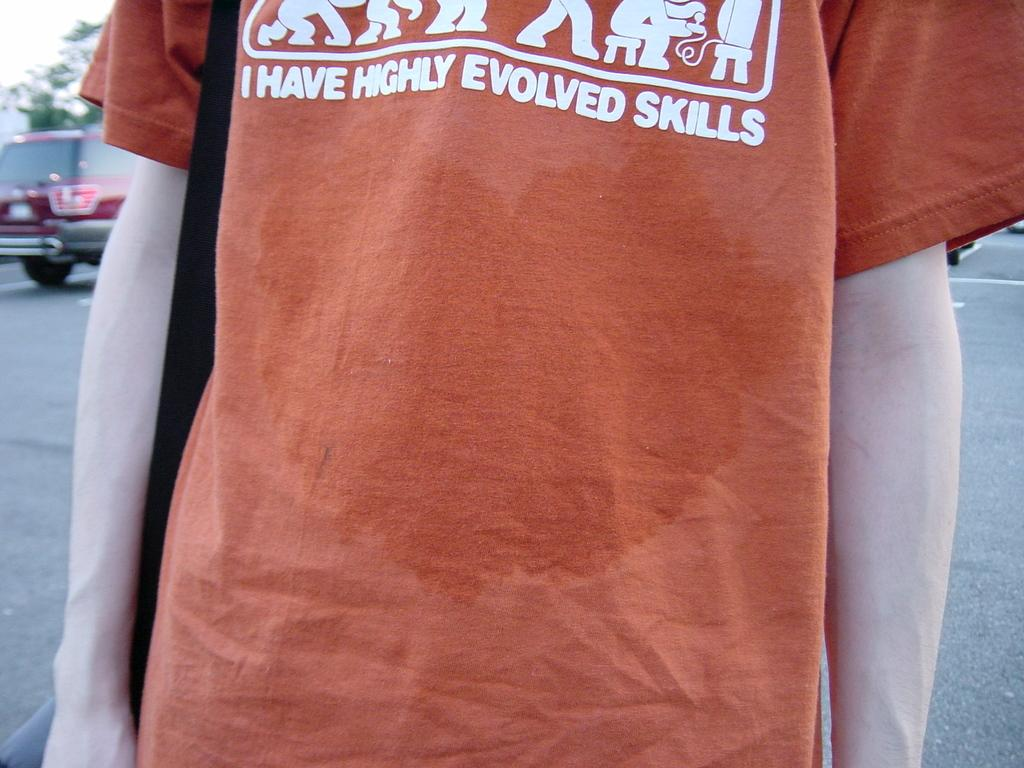<image>
Present a compact description of the photo's key features. The man wearing this t-shirt claims to have highly evolved skills. 